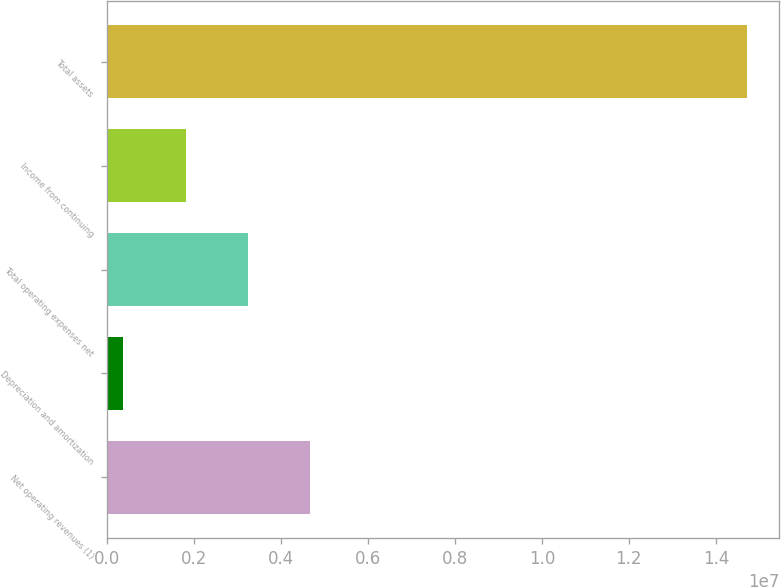<chart> <loc_0><loc_0><loc_500><loc_500><bar_chart><fcel>Net operating revenues (1)<fcel>Depreciation and amortization<fcel>Total operating expenses net<fcel>Income from continuing<fcel>Total assets<nl><fcel>4.68197e+06<fcel>380402<fcel>3.24812e+06<fcel>1.81426e+06<fcel>1.4719e+07<nl></chart> 